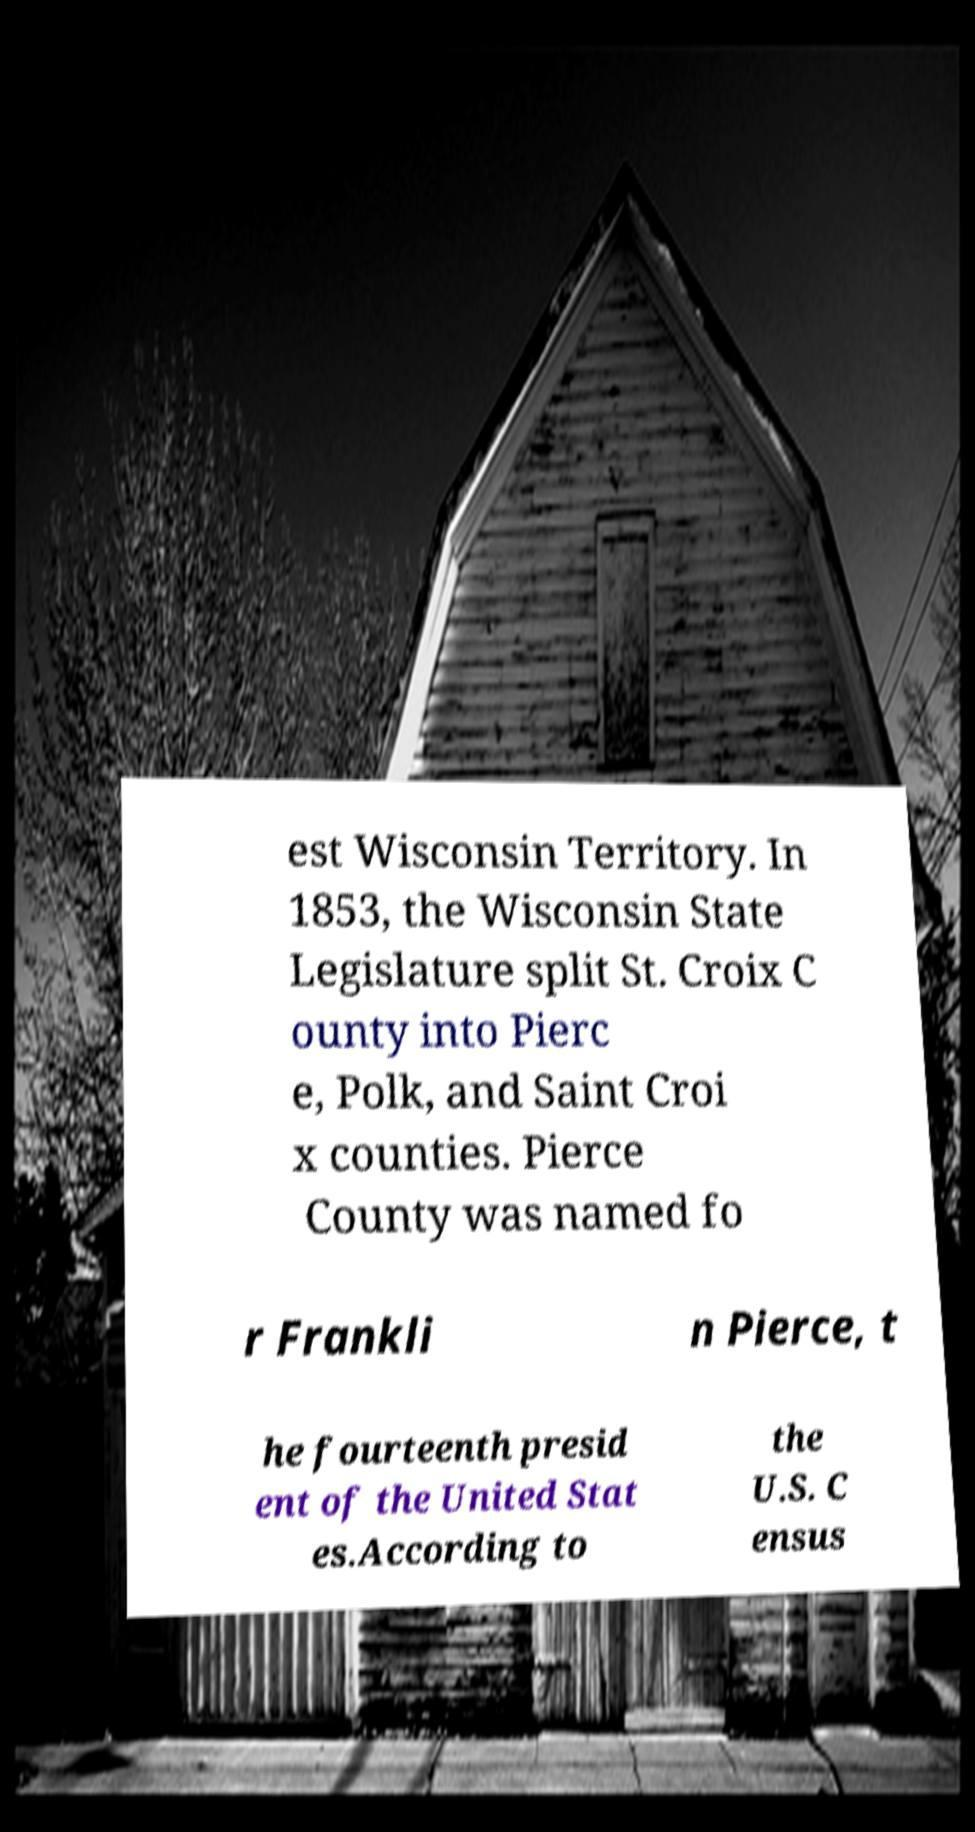I need the written content from this picture converted into text. Can you do that? est Wisconsin Territory. In 1853, the Wisconsin State Legislature split St. Croix C ounty into Pierc e, Polk, and Saint Croi x counties. Pierce County was named fo r Frankli n Pierce, t he fourteenth presid ent of the United Stat es.According to the U.S. C ensus 